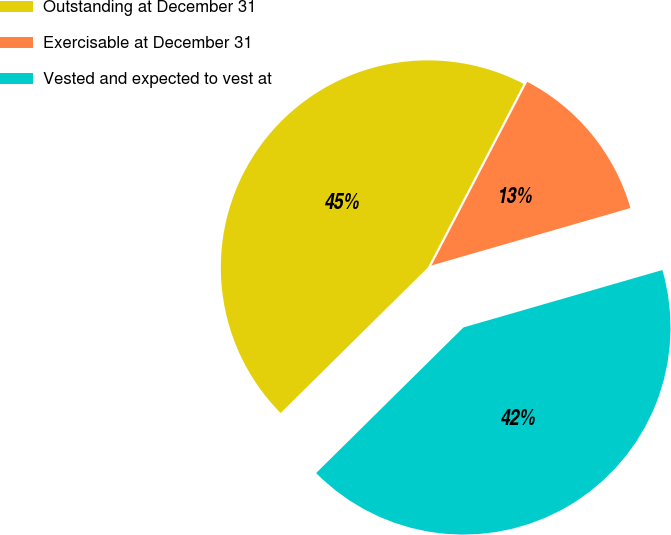<chart> <loc_0><loc_0><loc_500><loc_500><pie_chart><fcel>Outstanding at December 31<fcel>Exercisable at December 31<fcel>Vested and expected to vest at<nl><fcel>45.06%<fcel>12.88%<fcel>42.07%<nl></chart> 